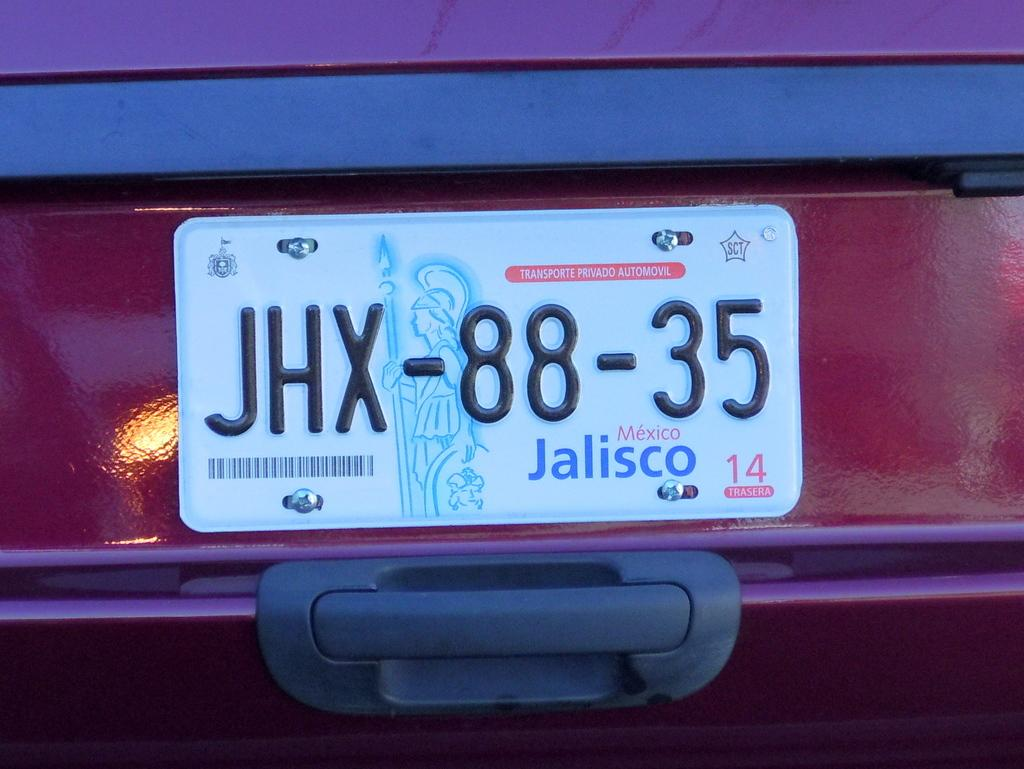<image>
Summarize the visual content of the image. Jalisco license plate that says JHX8835 on it. 